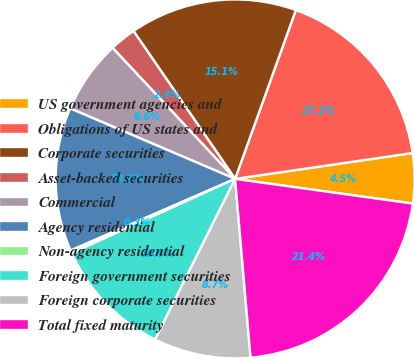<chart> <loc_0><loc_0><loc_500><loc_500><pie_chart><fcel>US government agencies and<fcel>Obligations of US states and<fcel>Corporate securities<fcel>Asset-backed securities<fcel>Commercial<fcel>Agency residential<fcel>Non-agency residential<fcel>Foreign government securities<fcel>Foreign corporate securities<fcel>Total fixed maturity<nl><fcel>4.5%<fcel>17.2%<fcel>15.08%<fcel>2.38%<fcel>6.61%<fcel>12.96%<fcel>0.26%<fcel>10.85%<fcel>8.73%<fcel>21.43%<nl></chart> 